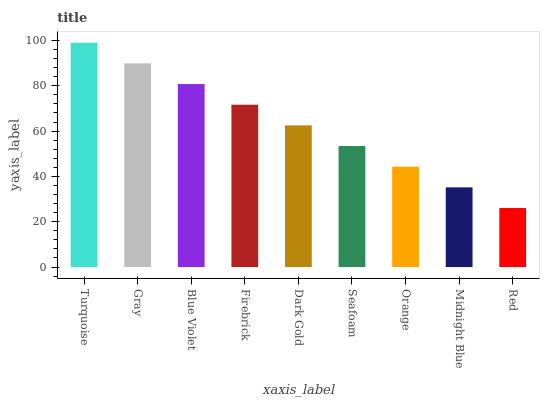Is Red the minimum?
Answer yes or no. Yes. Is Turquoise the maximum?
Answer yes or no. Yes. Is Gray the minimum?
Answer yes or no. No. Is Gray the maximum?
Answer yes or no. No. Is Turquoise greater than Gray?
Answer yes or no. Yes. Is Gray less than Turquoise?
Answer yes or no. Yes. Is Gray greater than Turquoise?
Answer yes or no. No. Is Turquoise less than Gray?
Answer yes or no. No. Is Dark Gold the high median?
Answer yes or no. Yes. Is Dark Gold the low median?
Answer yes or no. Yes. Is Seafoam the high median?
Answer yes or no. No. Is Turquoise the low median?
Answer yes or no. No. 